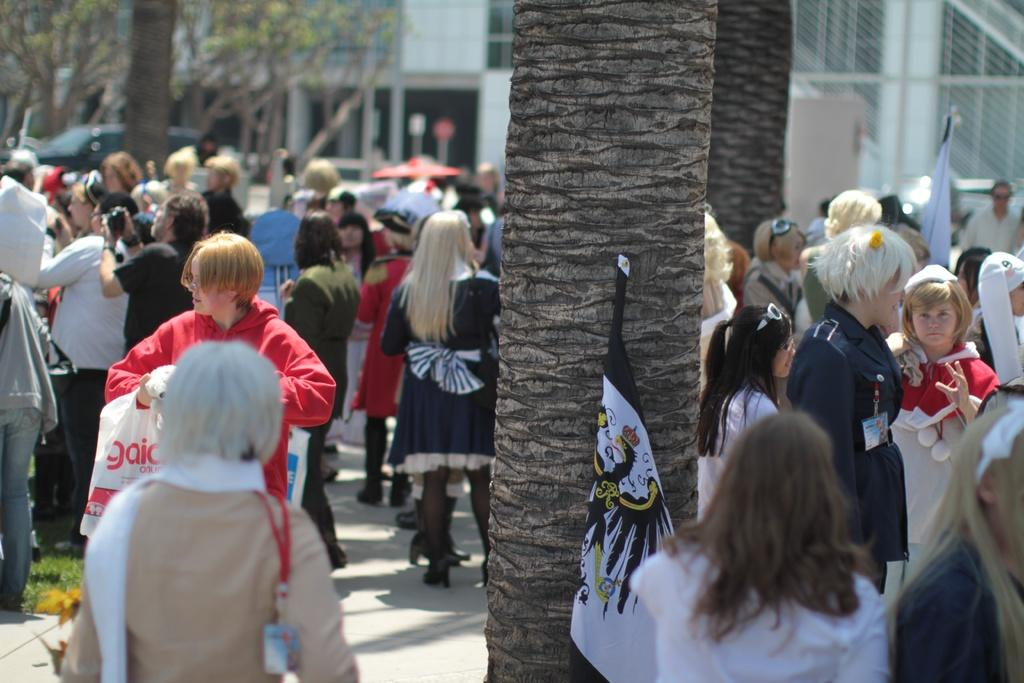What is the main subject of the image? The main subject of the image is a group of people standing. What can be seen in the background of the image? There is a building in the background of the image. What other objects or features are present in the image? There are trees and flags in the image. How many tomatoes are hanging from the trees in the image? There are no tomatoes present in the image; only trees are visible. What type of bead is being used to decorate the flags in the image? There are no beads present in the image; only flags are visible. 